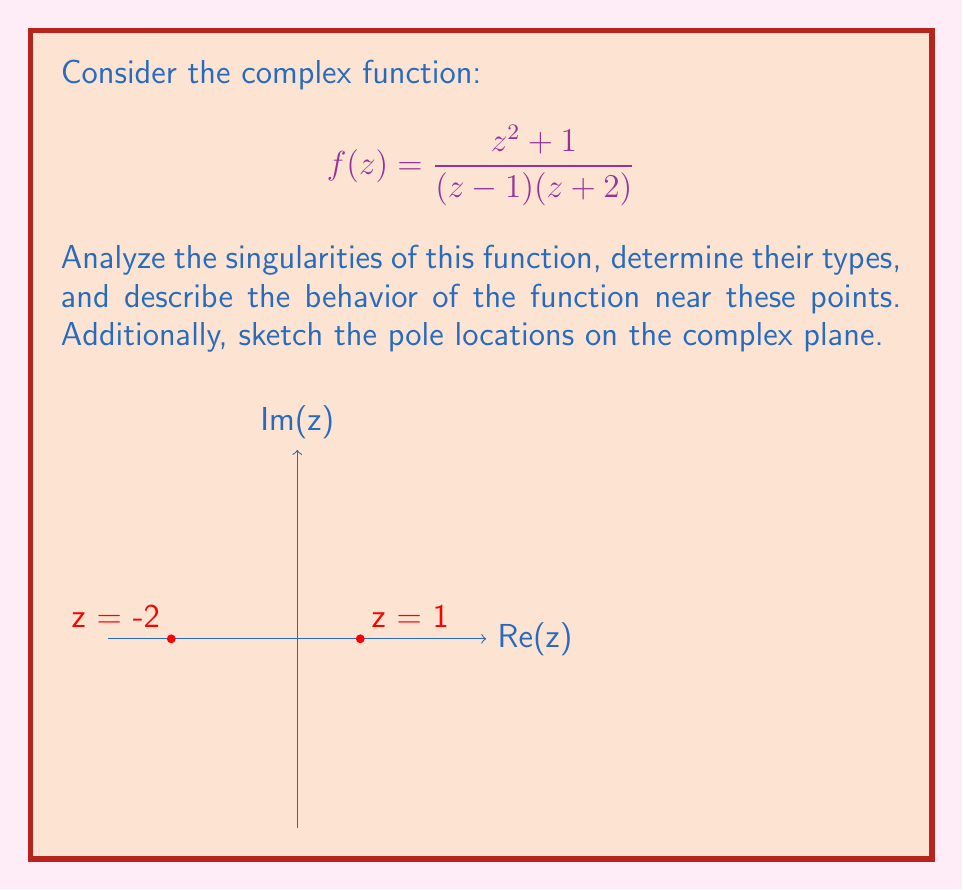What is the answer to this math problem? Let's analyze this function step by step:

1) First, we need to identify the singularities. The singularities occur where the denominator of the function is zero:
   $$(z - 1)(z + 2) = 0$$
   This gives us two points: $z = 1$ and $z = -2$

2) To determine the type of singularities, we need to factor the numerator and denominator:
   $$f(z) = \frac{z^2 + 1}{(z - 1)(z + 2)}$$

3) For $z = 1$:
   Let's substitute $z = 1 + h$ where $h$ approaches 0:
   $$f(1+h) = \frac{(1+h)^2 + 1}{((1+h) - 1)((1+h) + 2)} = \frac{1 + 2h + h^2 + 1}{h(3+h)} = \frac{2 + 2h + h^2}{h(3+h)}$$
   As $h \to 0$, this approaches infinity, but the numerator doesn't cancel with the denominator. Therefore, $z = 1$ is a simple pole.

4) For $z = -2$:
   Let's substitute $z = -2 + h$ where $h$ approaches 0:
   $$f(-2+h) = \frac{(-2+h)^2 + 1}{((-2+h) - 1)((-2+h) + 2)} = \frac{4 - 4h + h^2 + 1}{(-3+h)(h)} = \frac{5 - 4h + h^2}{-3h+h^2}$$
   As $h \to 0$, this approaches infinity, but the numerator doesn't cancel with the denominator. Therefore, $z = -2$ is also a simple pole.

5) Behavior near the poles:
   - Near $z = 1$: As $z$ approaches 1, $|f(z)|$ grows without bound.
   - Near $z = -2$: As $z$ approaches -2, $|f(z)|$ also grows without bound.

6) The function is analytic (holomorphic) everywhere except at these two poles.

7) The residue at each pole can be calculated, but it's not necessary for this analysis.
Answer: $f(z)$ has simple poles at $z = 1$ and $z = -2$. $|f(z)|$ approaches infinity as $z$ approaches either pole. 